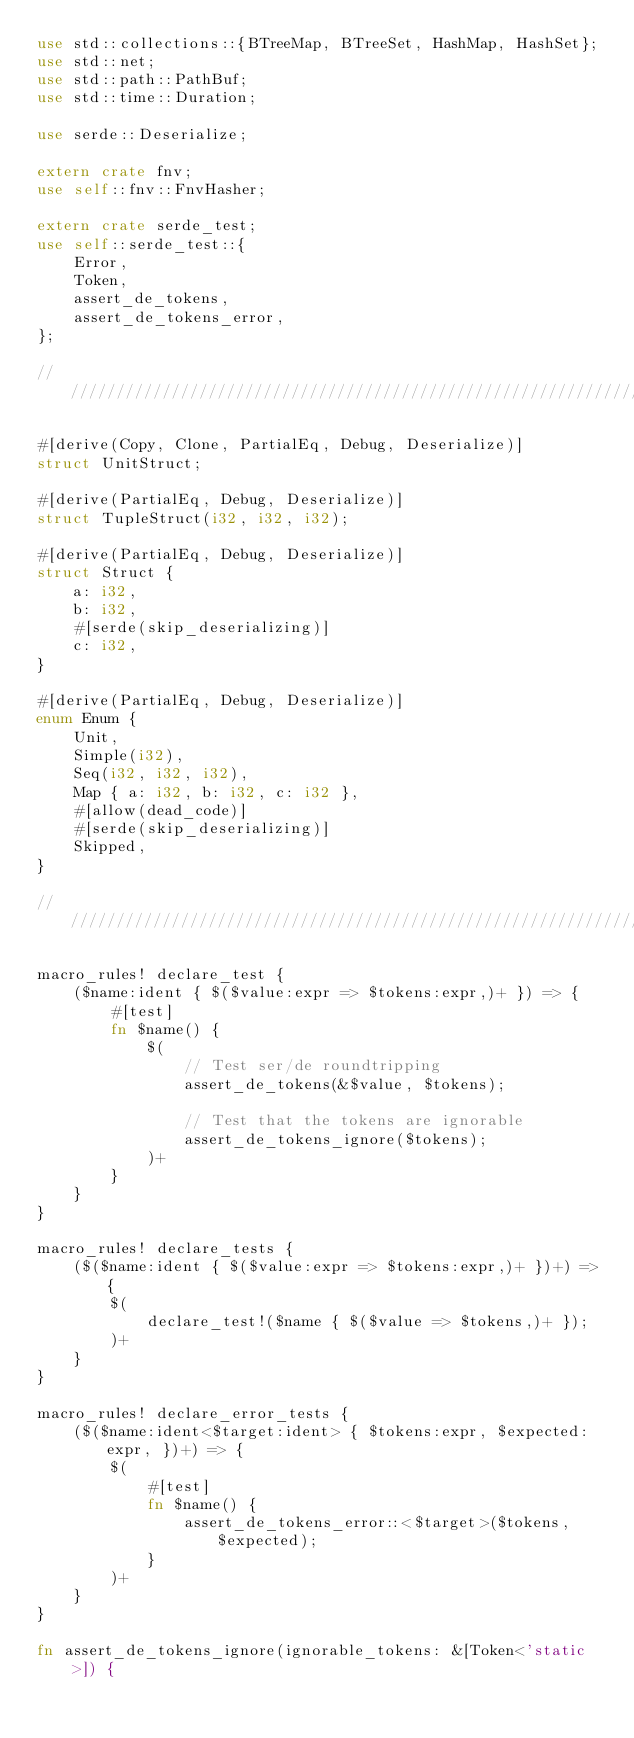<code> <loc_0><loc_0><loc_500><loc_500><_Rust_>use std::collections::{BTreeMap, BTreeSet, HashMap, HashSet};
use std::net;
use std::path::PathBuf;
use std::time::Duration;

use serde::Deserialize;

extern crate fnv;
use self::fnv::FnvHasher;

extern crate serde_test;
use self::serde_test::{
    Error,
    Token,
    assert_de_tokens,
    assert_de_tokens_error,
};

//////////////////////////////////////////////////////////////////////////

#[derive(Copy, Clone, PartialEq, Debug, Deserialize)]
struct UnitStruct;

#[derive(PartialEq, Debug, Deserialize)]
struct TupleStruct(i32, i32, i32);

#[derive(PartialEq, Debug, Deserialize)]
struct Struct {
    a: i32,
    b: i32,
    #[serde(skip_deserializing)]
    c: i32,
}

#[derive(PartialEq, Debug, Deserialize)]
enum Enum {
    Unit,
    Simple(i32),
    Seq(i32, i32, i32),
    Map { a: i32, b: i32, c: i32 },
    #[allow(dead_code)]
    #[serde(skip_deserializing)]
    Skipped,
}

//////////////////////////////////////////////////////////////////////////

macro_rules! declare_test {
    ($name:ident { $($value:expr => $tokens:expr,)+ }) => {
        #[test]
        fn $name() {
            $(
                // Test ser/de roundtripping
                assert_de_tokens(&$value, $tokens);

                // Test that the tokens are ignorable
                assert_de_tokens_ignore($tokens);
            )+
        }
    }
}

macro_rules! declare_tests {
    ($($name:ident { $($value:expr => $tokens:expr,)+ })+) => {
        $(
            declare_test!($name { $($value => $tokens,)+ });
        )+
    }
}

macro_rules! declare_error_tests {
    ($($name:ident<$target:ident> { $tokens:expr, $expected:expr, })+) => {
        $(
            #[test]
            fn $name() {
                assert_de_tokens_error::<$target>($tokens, $expected);
            }
        )+
    }
}

fn assert_de_tokens_ignore(ignorable_tokens: &[Token<'static>]) {</code> 